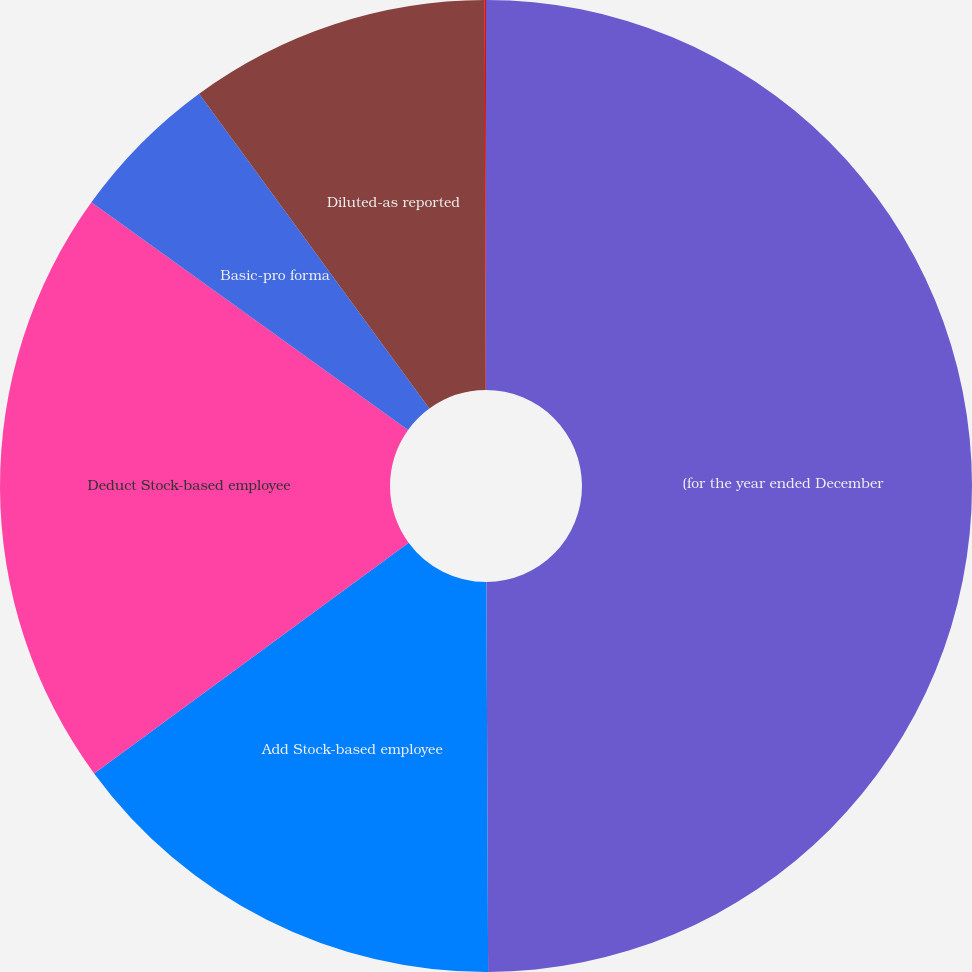Convert chart. <chart><loc_0><loc_0><loc_500><loc_500><pie_chart><fcel>(for the year ended December<fcel>Add Stock-based employee<fcel>Deduct Stock-based employee<fcel>Basic-pro forma<fcel>Diluted-as reported<fcel>Diluted-pro forma<nl><fcel>49.93%<fcel>15.0%<fcel>19.99%<fcel>5.03%<fcel>10.01%<fcel>0.04%<nl></chart> 